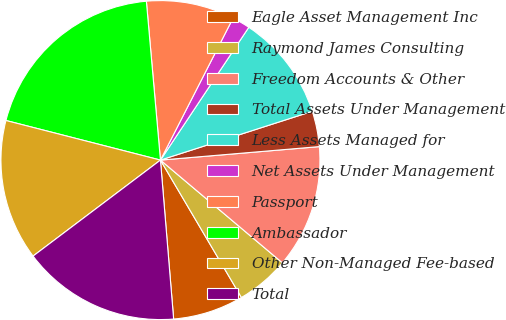Convert chart to OTSL. <chart><loc_0><loc_0><loc_500><loc_500><pie_chart><fcel>Eagle Asset Management Inc<fcel>Raymond James Consulting<fcel>Freedom Accounts & Other<fcel>Total Assets Under Management<fcel>Less Assets Managed for<fcel>Net Assets Under Management<fcel>Passport<fcel>Ambassador<fcel>Other Non-Managed Fee-based<fcel>Total<nl><fcel>7.16%<fcel>5.38%<fcel>12.49%<fcel>3.6%<fcel>10.71%<fcel>1.82%<fcel>8.93%<fcel>19.6%<fcel>14.27%<fcel>16.04%<nl></chart> 